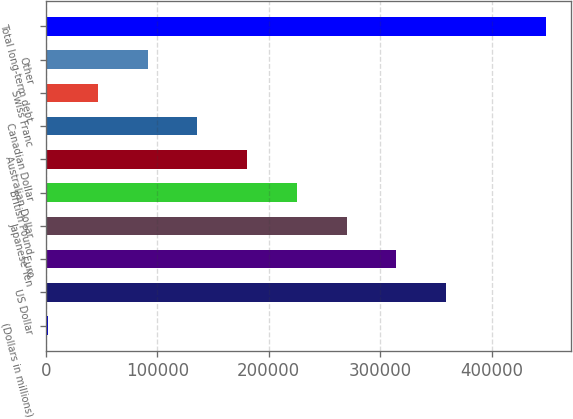<chart> <loc_0><loc_0><loc_500><loc_500><bar_chart><fcel>(Dollars in millions)<fcel>US Dollar<fcel>Euro<fcel>Japanese Yen<fcel>British Pound<fcel>Australian Dollar<fcel>Canadian Dollar<fcel>Swiss Franc<fcel>Other<fcel>Total long-term debt<nl><fcel>2010<fcel>359147<fcel>314505<fcel>269863<fcel>225220<fcel>180578<fcel>135936<fcel>46652.1<fcel>91294.2<fcel>448431<nl></chart> 